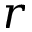<formula> <loc_0><loc_0><loc_500><loc_500>r</formula> 